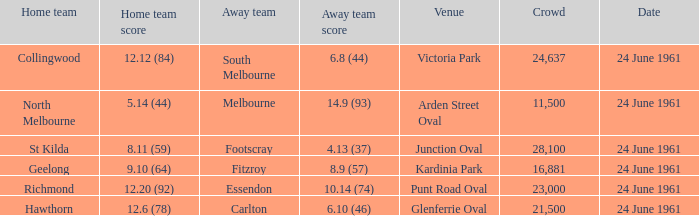Give me the full table as a dictionary. {'header': ['Home team', 'Home team score', 'Away team', 'Away team score', 'Venue', 'Crowd', 'Date'], 'rows': [['Collingwood', '12.12 (84)', 'South Melbourne', '6.8 (44)', 'Victoria Park', '24,637', '24 June 1961'], ['North Melbourne', '5.14 (44)', 'Melbourne', '14.9 (93)', 'Arden Street Oval', '11,500', '24 June 1961'], ['St Kilda', '8.11 (59)', 'Footscray', '4.13 (37)', 'Junction Oval', '28,100', '24 June 1961'], ['Geelong', '9.10 (64)', 'Fitzroy', '8.9 (57)', 'Kardinia Park', '16,881', '24 June 1961'], ['Richmond', '12.20 (92)', 'Essendon', '10.14 (74)', 'Punt Road Oval', '23,000', '24 June 1961'], ['Hawthorn', '12.6 (78)', 'Carlton', '6.10 (46)', 'Glenferrie Oval', '21,500', '24 June 1961']]} What is the date of the game where the home team scored 9.10 (64)? 24 June 1961. 